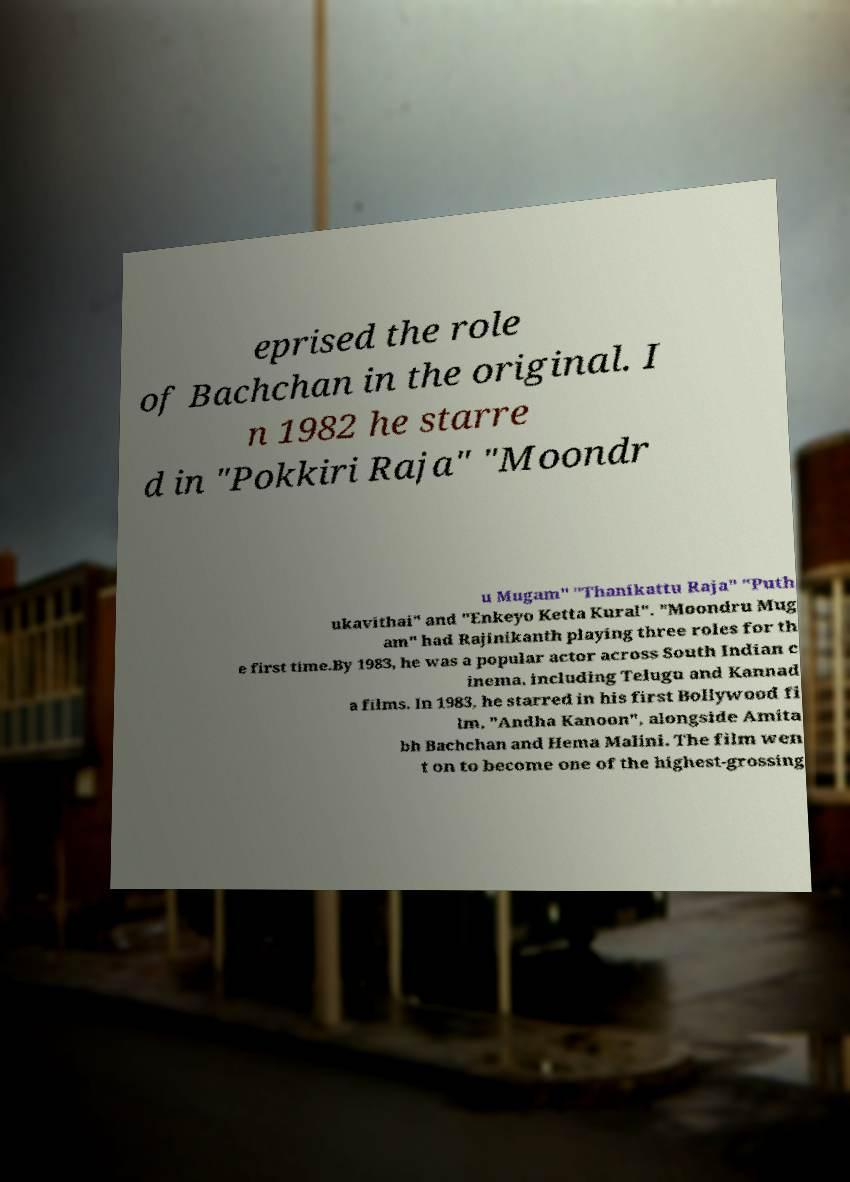Could you assist in decoding the text presented in this image and type it out clearly? eprised the role of Bachchan in the original. I n 1982 he starre d in "Pokkiri Raja" "Moondr u Mugam" "Thanikattu Raja" "Puth ukavithai" and "Enkeyo Ketta Kural". "Moondru Mug am" had Rajinikanth playing three roles for th e first time.By 1983, he was a popular actor across South Indian c inema, including Telugu and Kannad a films. In 1983, he starred in his first Bollywood fi lm, "Andha Kanoon", alongside Amita bh Bachchan and Hema Malini. The film wen t on to become one of the highest-grossing 